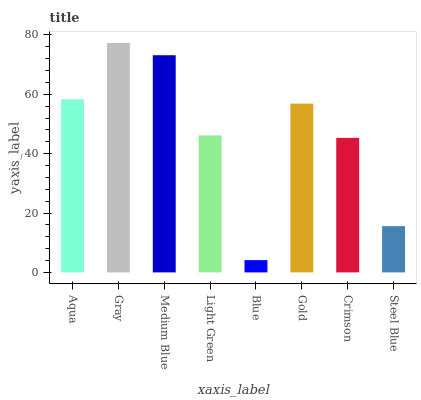Is Medium Blue the minimum?
Answer yes or no. No. Is Medium Blue the maximum?
Answer yes or no. No. Is Gray greater than Medium Blue?
Answer yes or no. Yes. Is Medium Blue less than Gray?
Answer yes or no. Yes. Is Medium Blue greater than Gray?
Answer yes or no. No. Is Gray less than Medium Blue?
Answer yes or no. No. Is Gold the high median?
Answer yes or no. Yes. Is Light Green the low median?
Answer yes or no. Yes. Is Blue the high median?
Answer yes or no. No. Is Crimson the low median?
Answer yes or no. No. 